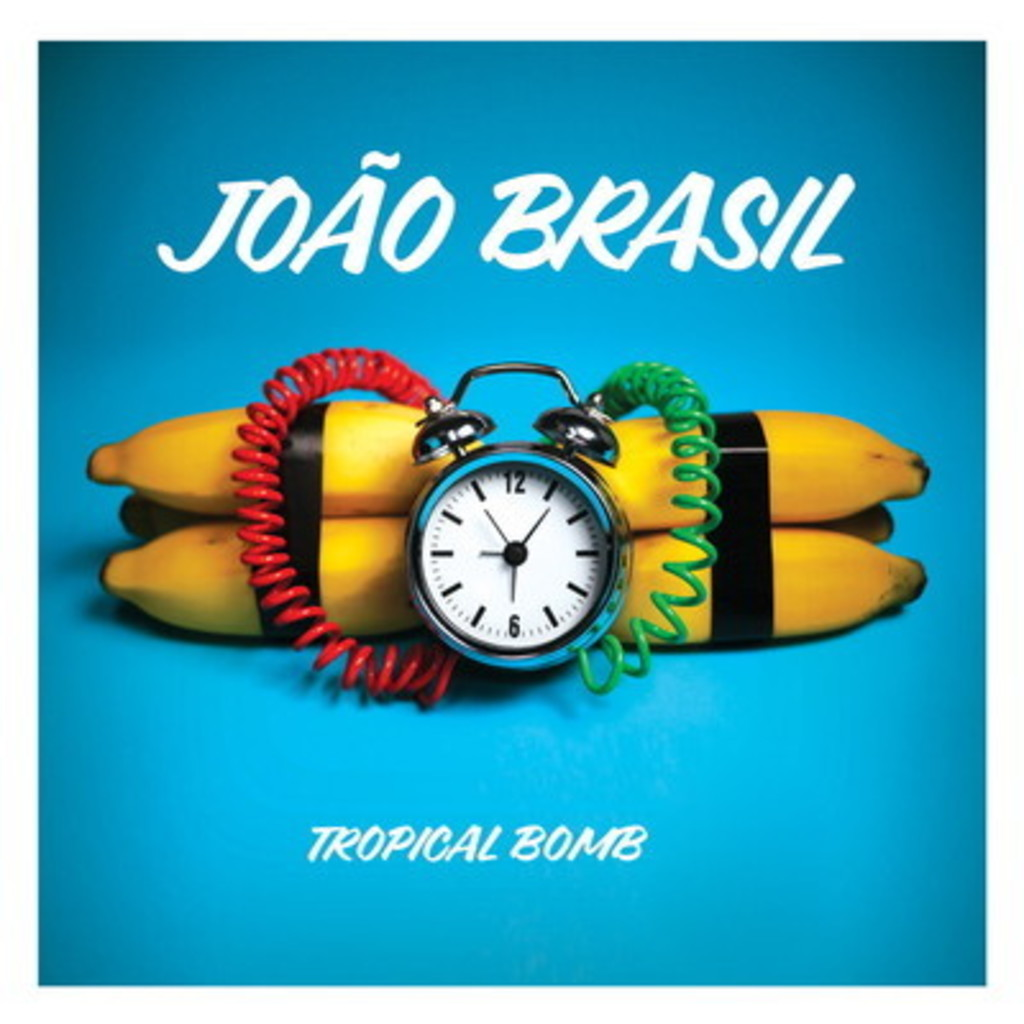How do the colors on the album cover contribute to its visual impact? The use of bright primary colors such as blue, red, yellow, and green grabs attention and infuses the album cover with a lively, tropical feel. The deep blue background makes the yellow bananas and the colorful cords stand out, emphasizing the central theme of the album. These choices likely aim to evoke feelings of fun, vibrancy, and the energetic beats typical of João Brasil's music style. 